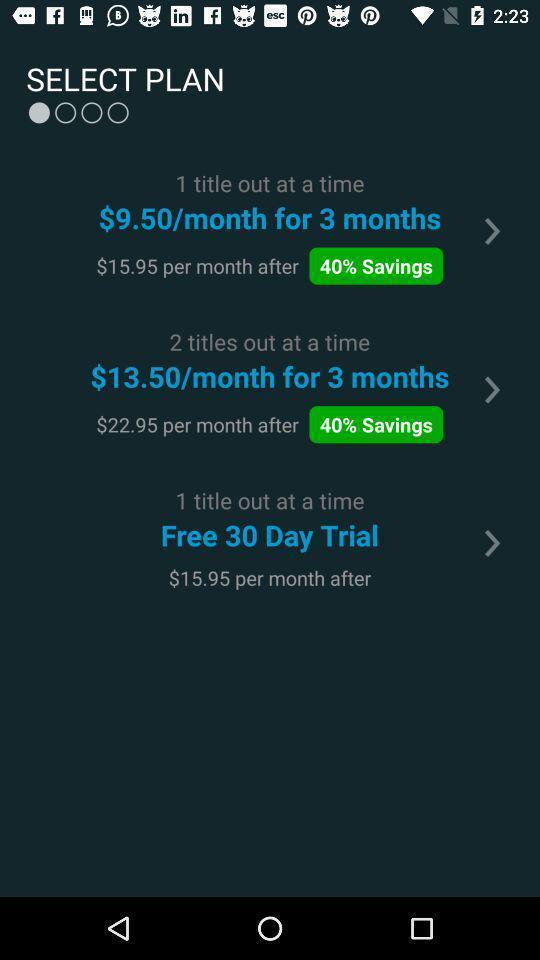Explain what's happening in this screen capture. Page displays to select a plan in app. 